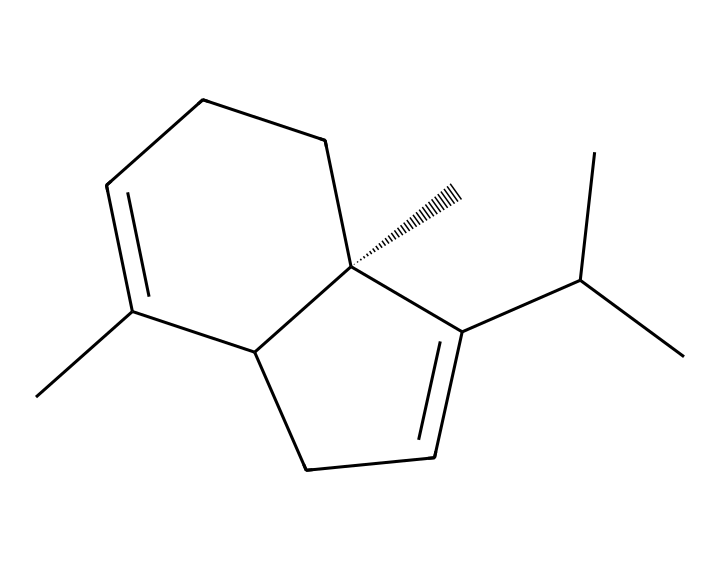How many carbon atoms are in caryophyllene? By analyzing the SMILES representation, we can count the number of carbon atoms (C) in the structure. The notation indicates multiple carbon atoms connected in various configurations. Counting them yields a total of 15 carbon atoms.
Answer: 15 What is the molecular formula of caryophyllene? From the SMILES provided, we can derive the molecular formula by counting carbon (C), hydrogen (H), and any other atoms present (in this case, there are no other atoms). We found 15 carbons and 24 hydrogens, leading to the formula C15H24.
Answer: C15H24 Is caryophyllene a cyclic compound? The presence of a ring structure can be inferred from the SMILES notation, where repeated numbering indicates the beginning and ending of rings. Indeed, caryophyllene has two cyclic structures, confirming it is a cyclic compound.
Answer: Yes What type of terpene is caryophyllene? Caryophyllene contains a specific arrangement and structure categorized as a bicyclic terpene due to its multiple rings and distinct molecular framework. This classification helps understand its properties and applications.
Answer: Bicyclic What functional groups can be seen in caryophyllene? By closely examining the SMILES representation, we can identify that caryophyllene primarily exhibits a hydrocarbon structure without any additional functional groups such as alcohols or carboxylic acids. Therefore, it contains zero functional groups.
Answer: Zero 